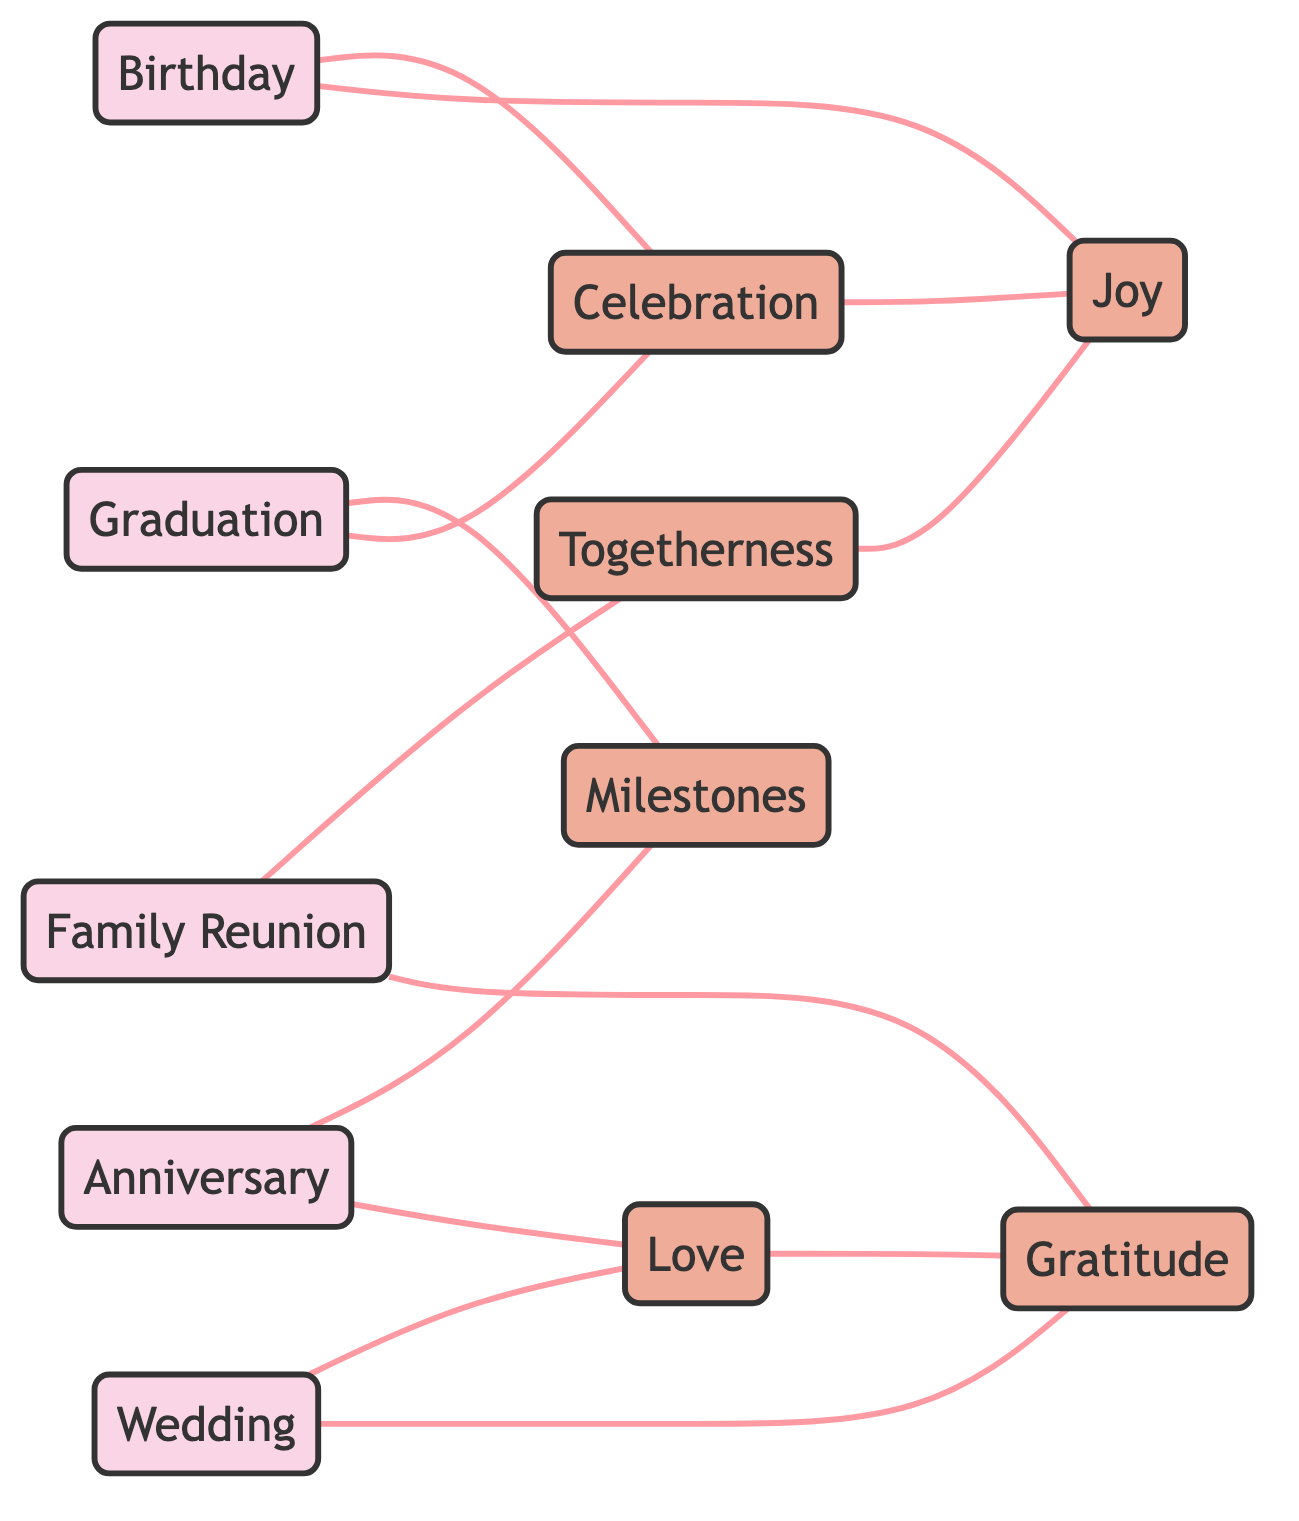What are the total number of nodes in the diagram? The diagram consists of 11 nodes which represent the family events and lyrical themes. Each node is a unique element in the graph.
Answer: 11 How many edges are connecting the "Graduation" event? "Graduation" is connected to two themes: "Milestones" and "Celebration." By counting the links, we find that it has two edges associated with it.
Answer: 2 What theme is connected to both "Family Reunion" and "Graduation"? By analyzing the connections, the only theme that connects to both "Family Reunion" and "Graduation" is "Gratitude." This shows the overlap in sentiments associated with these events.
Answer: Gratitude Which two events are both connected to "Love"? The events "Wedding" and "Anniversary" are both connected to the theme "Love." Each of these events emphasizes the concept of love in their celebrations, as described in the diagram.
Answer: Wedding, Anniversary What is the relationship between "Birthday" and "Joy"? There is a direct link between "Birthday" and "Joy," indicating that joy is a sentiment associated with birthdays in the diagram. This shows how birthday celebrations often evoke feelings of happiness.
Answer: Joy Which theme is linked to the most events? Upon examination, the theme "Gratitude" is linked to three different events: "Wedding," "Family Reunion," and "Anniversary." This suggests that gratitude is a frequent sentiment shared across multiple family occasions.
Answer: Gratitude What is the relationship between "Love" and "Celebration"? There is no direct edge connecting "Love" to "Celebration," meaning they do not share a direct relationship in the diagram structure. However, both themes are related to various events, reflecting a connection through other nodes.
Answer: None Count the number of edges connected to the theme "Joy." The theme "Joy" appears to be connected to three different events: "Birthday," "Celebration," and "Togetherness." By counting these edges, we arrive at a total of three.
Answer: 3 What is the significance of "Milestones" in the diagram? "Milestones" connects both "Graduation" and "Anniversary," indicating that this theme signifies important achievements or moments within family events. With these connections, milestones represent key life stages in family narratives.
Answer: Important achievements 